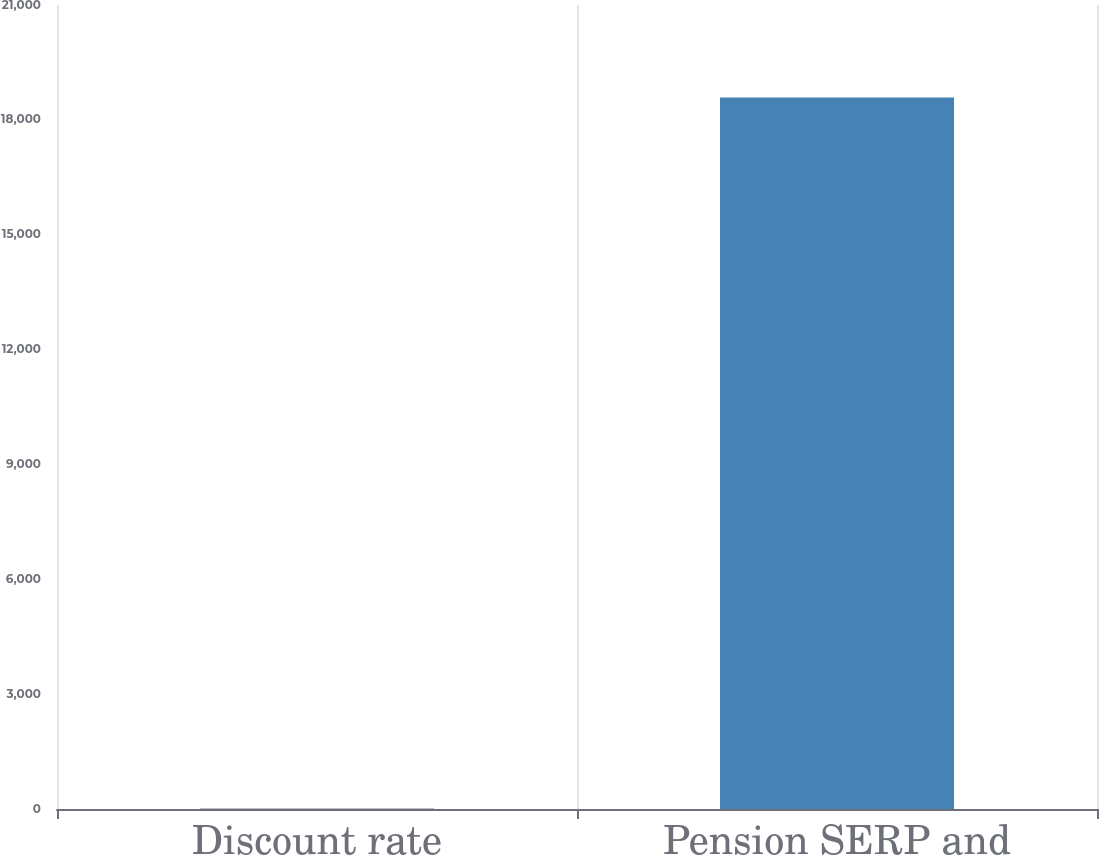<chart> <loc_0><loc_0><loc_500><loc_500><bar_chart><fcel>Discount rate<fcel>Pension SERP and<nl><fcel>4<fcel>18587<nl></chart> 